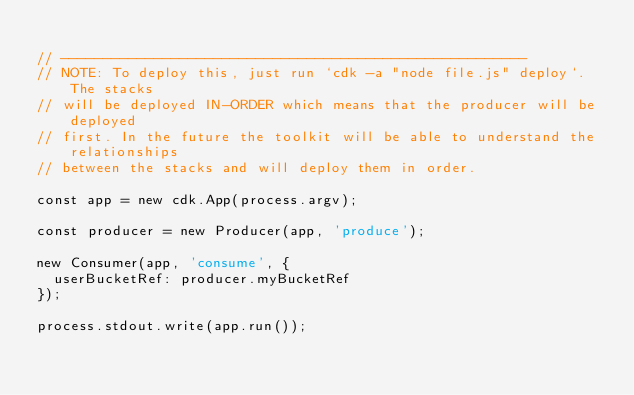Convert code to text. <code><loc_0><loc_0><loc_500><loc_500><_TypeScript_>
// -------------------------------------------------------
// NOTE: To deploy this, just run `cdk -a "node file.js" deploy`. The stacks
// will be deployed IN-ORDER which means that the producer will be deployed
// first. In the future the toolkit will be able to understand the relationships
// between the stacks and will deploy them in order.

const app = new cdk.App(process.argv);

const producer = new Producer(app, 'produce');

new Consumer(app, 'consume', {
  userBucketRef: producer.myBucketRef
});

process.stdout.write(app.run());
</code> 